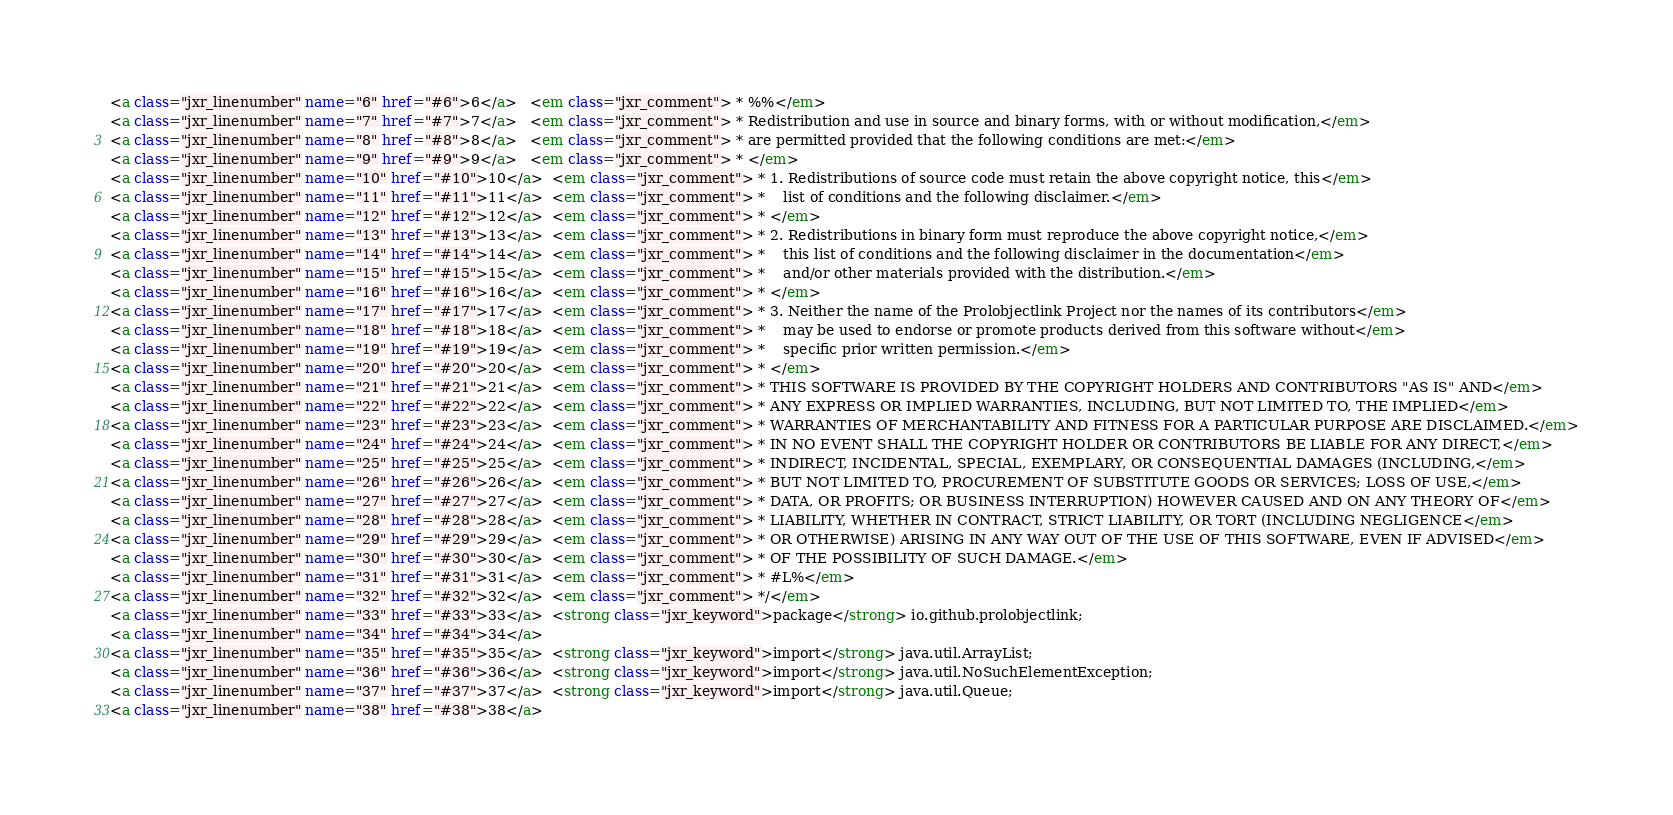<code> <loc_0><loc_0><loc_500><loc_500><_HTML_><a class="jxr_linenumber" name="6" href="#6">6</a>   <em class="jxr_comment"> * %%</em>
<a class="jxr_linenumber" name="7" href="#7">7</a>   <em class="jxr_comment"> * Redistribution and use in source and binary forms, with or without modification,</em>
<a class="jxr_linenumber" name="8" href="#8">8</a>   <em class="jxr_comment"> * are permitted provided that the following conditions are met:</em>
<a class="jxr_linenumber" name="9" href="#9">9</a>   <em class="jxr_comment"> * </em>
<a class="jxr_linenumber" name="10" href="#10">10</a>  <em class="jxr_comment"> * 1. Redistributions of source code must retain the above copyright notice, this</em>
<a class="jxr_linenumber" name="11" href="#11">11</a>  <em class="jxr_comment"> *    list of conditions and the following disclaimer.</em>
<a class="jxr_linenumber" name="12" href="#12">12</a>  <em class="jxr_comment"> * </em>
<a class="jxr_linenumber" name="13" href="#13">13</a>  <em class="jxr_comment"> * 2. Redistributions in binary form must reproduce the above copyright notice,</em>
<a class="jxr_linenumber" name="14" href="#14">14</a>  <em class="jxr_comment"> *    this list of conditions and the following disclaimer in the documentation</em>
<a class="jxr_linenumber" name="15" href="#15">15</a>  <em class="jxr_comment"> *    and/or other materials provided with the distribution.</em>
<a class="jxr_linenumber" name="16" href="#16">16</a>  <em class="jxr_comment"> * </em>
<a class="jxr_linenumber" name="17" href="#17">17</a>  <em class="jxr_comment"> * 3. Neither the name of the Prolobjectlink Project nor the names of its contributors</em>
<a class="jxr_linenumber" name="18" href="#18">18</a>  <em class="jxr_comment"> *    may be used to endorse or promote products derived from this software without</em>
<a class="jxr_linenumber" name="19" href="#19">19</a>  <em class="jxr_comment"> *    specific prior written permission.</em>
<a class="jxr_linenumber" name="20" href="#20">20</a>  <em class="jxr_comment"> * </em>
<a class="jxr_linenumber" name="21" href="#21">21</a>  <em class="jxr_comment"> * THIS SOFTWARE IS PROVIDED BY THE COPYRIGHT HOLDERS AND CONTRIBUTORS "AS IS" AND</em>
<a class="jxr_linenumber" name="22" href="#22">22</a>  <em class="jxr_comment"> * ANY EXPRESS OR IMPLIED WARRANTIES, INCLUDING, BUT NOT LIMITED TO, THE IMPLIED</em>
<a class="jxr_linenumber" name="23" href="#23">23</a>  <em class="jxr_comment"> * WARRANTIES OF MERCHANTABILITY AND FITNESS FOR A PARTICULAR PURPOSE ARE DISCLAIMED.</em>
<a class="jxr_linenumber" name="24" href="#24">24</a>  <em class="jxr_comment"> * IN NO EVENT SHALL THE COPYRIGHT HOLDER OR CONTRIBUTORS BE LIABLE FOR ANY DIRECT,</em>
<a class="jxr_linenumber" name="25" href="#25">25</a>  <em class="jxr_comment"> * INDIRECT, INCIDENTAL, SPECIAL, EXEMPLARY, OR CONSEQUENTIAL DAMAGES (INCLUDING,</em>
<a class="jxr_linenumber" name="26" href="#26">26</a>  <em class="jxr_comment"> * BUT NOT LIMITED TO, PROCUREMENT OF SUBSTITUTE GOODS OR SERVICES; LOSS OF USE,</em>
<a class="jxr_linenumber" name="27" href="#27">27</a>  <em class="jxr_comment"> * DATA, OR PROFITS; OR BUSINESS INTERRUPTION) HOWEVER CAUSED AND ON ANY THEORY OF</em>
<a class="jxr_linenumber" name="28" href="#28">28</a>  <em class="jxr_comment"> * LIABILITY, WHETHER IN CONTRACT, STRICT LIABILITY, OR TORT (INCLUDING NEGLIGENCE</em>
<a class="jxr_linenumber" name="29" href="#29">29</a>  <em class="jxr_comment"> * OR OTHERWISE) ARISING IN ANY WAY OUT OF THE USE OF THIS SOFTWARE, EVEN IF ADVISED</em>
<a class="jxr_linenumber" name="30" href="#30">30</a>  <em class="jxr_comment"> * OF THE POSSIBILITY OF SUCH DAMAGE.</em>
<a class="jxr_linenumber" name="31" href="#31">31</a>  <em class="jxr_comment"> * #L%</em>
<a class="jxr_linenumber" name="32" href="#32">32</a>  <em class="jxr_comment"> */</em>
<a class="jxr_linenumber" name="33" href="#33">33</a>  <strong class="jxr_keyword">package</strong> io.github.prolobjectlink;
<a class="jxr_linenumber" name="34" href="#34">34</a>  
<a class="jxr_linenumber" name="35" href="#35">35</a>  <strong class="jxr_keyword">import</strong> java.util.ArrayList;
<a class="jxr_linenumber" name="36" href="#36">36</a>  <strong class="jxr_keyword">import</strong> java.util.NoSuchElementException;
<a class="jxr_linenumber" name="37" href="#37">37</a>  <strong class="jxr_keyword">import</strong> java.util.Queue;
<a class="jxr_linenumber" name="38" href="#38">38</a>  </code> 